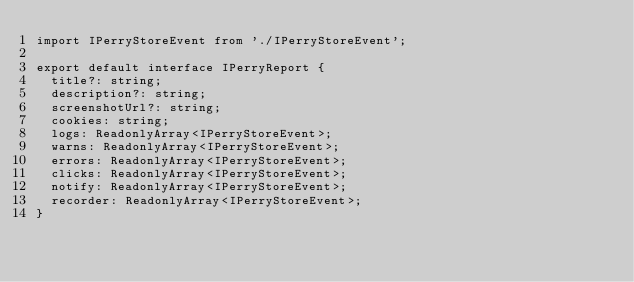Convert code to text. <code><loc_0><loc_0><loc_500><loc_500><_TypeScript_>import IPerryStoreEvent from './IPerryStoreEvent';

export default interface IPerryReport {
  title?: string;
  description?: string;
  screenshotUrl?: string;
  cookies: string;
  logs: ReadonlyArray<IPerryStoreEvent>;
  warns: ReadonlyArray<IPerryStoreEvent>;
  errors: ReadonlyArray<IPerryStoreEvent>;
  clicks: ReadonlyArray<IPerryStoreEvent>;
  notify: ReadonlyArray<IPerryStoreEvent>;
  recorder: ReadonlyArray<IPerryStoreEvent>;
}
</code> 